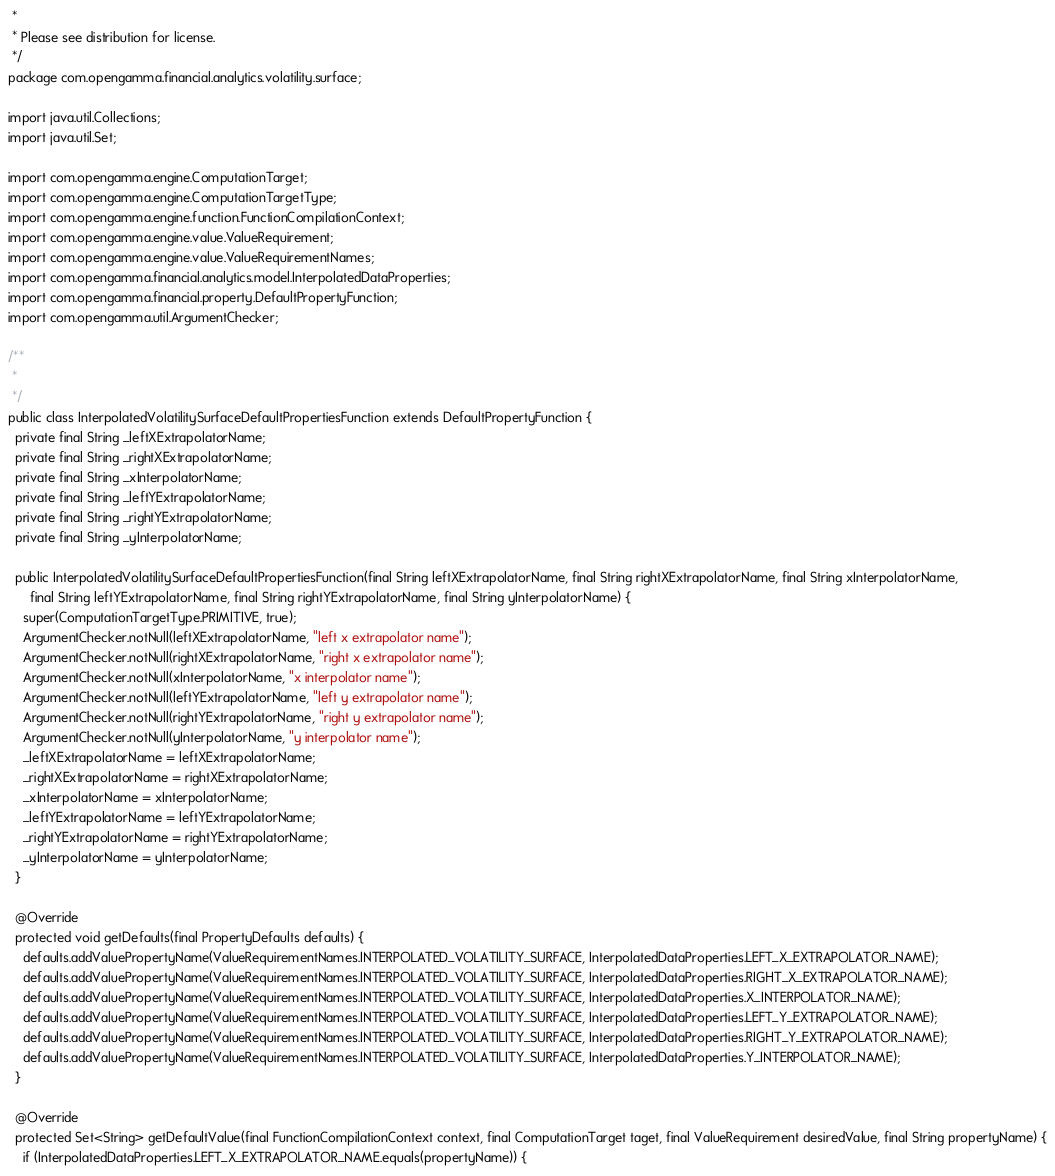Convert code to text. <code><loc_0><loc_0><loc_500><loc_500><_Java_> * 
 * Please see distribution for license.
 */
package com.opengamma.financial.analytics.volatility.surface;

import java.util.Collections;
import java.util.Set;

import com.opengamma.engine.ComputationTarget;
import com.opengamma.engine.ComputationTargetType;
import com.opengamma.engine.function.FunctionCompilationContext;
import com.opengamma.engine.value.ValueRequirement;
import com.opengamma.engine.value.ValueRequirementNames;
import com.opengamma.financial.analytics.model.InterpolatedDataProperties;
import com.opengamma.financial.property.DefaultPropertyFunction;
import com.opengamma.util.ArgumentChecker;

/**
 * 
 */
public class InterpolatedVolatilitySurfaceDefaultPropertiesFunction extends DefaultPropertyFunction {
  private final String _leftXExtrapolatorName;
  private final String _rightXExtrapolatorName;
  private final String _xInterpolatorName;
  private final String _leftYExtrapolatorName;
  private final String _rightYExtrapolatorName;
  private final String _yInterpolatorName;

  public InterpolatedVolatilitySurfaceDefaultPropertiesFunction(final String leftXExtrapolatorName, final String rightXExtrapolatorName, final String xInterpolatorName,
      final String leftYExtrapolatorName, final String rightYExtrapolatorName, final String yInterpolatorName) {
    super(ComputationTargetType.PRIMITIVE, true);
    ArgumentChecker.notNull(leftXExtrapolatorName, "left x extrapolator name");
    ArgumentChecker.notNull(rightXExtrapolatorName, "right x extrapolator name");
    ArgumentChecker.notNull(xInterpolatorName, "x interpolator name");
    ArgumentChecker.notNull(leftYExtrapolatorName, "left y extrapolator name");
    ArgumentChecker.notNull(rightYExtrapolatorName, "right y extrapolator name");
    ArgumentChecker.notNull(yInterpolatorName, "y interpolator name");
    _leftXExtrapolatorName = leftXExtrapolatorName;
    _rightXExtrapolatorName = rightXExtrapolatorName;
    _xInterpolatorName = xInterpolatorName;
    _leftYExtrapolatorName = leftYExtrapolatorName;
    _rightYExtrapolatorName = rightYExtrapolatorName;
    _yInterpolatorName = yInterpolatorName;
  }

  @Override
  protected void getDefaults(final PropertyDefaults defaults) {
    defaults.addValuePropertyName(ValueRequirementNames.INTERPOLATED_VOLATILITY_SURFACE, InterpolatedDataProperties.LEFT_X_EXTRAPOLATOR_NAME);
    defaults.addValuePropertyName(ValueRequirementNames.INTERPOLATED_VOLATILITY_SURFACE, InterpolatedDataProperties.RIGHT_X_EXTRAPOLATOR_NAME);
    defaults.addValuePropertyName(ValueRequirementNames.INTERPOLATED_VOLATILITY_SURFACE, InterpolatedDataProperties.X_INTERPOLATOR_NAME);
    defaults.addValuePropertyName(ValueRequirementNames.INTERPOLATED_VOLATILITY_SURFACE, InterpolatedDataProperties.LEFT_Y_EXTRAPOLATOR_NAME);
    defaults.addValuePropertyName(ValueRequirementNames.INTERPOLATED_VOLATILITY_SURFACE, InterpolatedDataProperties.RIGHT_Y_EXTRAPOLATOR_NAME);
    defaults.addValuePropertyName(ValueRequirementNames.INTERPOLATED_VOLATILITY_SURFACE, InterpolatedDataProperties.Y_INTERPOLATOR_NAME);
  }

  @Override
  protected Set<String> getDefaultValue(final FunctionCompilationContext context, final ComputationTarget taget, final ValueRequirement desiredValue, final String propertyName) {
    if (InterpolatedDataProperties.LEFT_X_EXTRAPOLATOR_NAME.equals(propertyName)) {</code> 